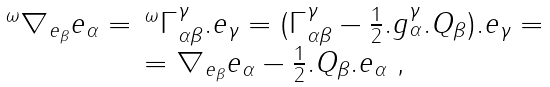<formula> <loc_0><loc_0><loc_500><loc_500>\begin{array} { c } ^ { \omega } \nabla _ { e _ { \beta } } e _ { \alpha } = \, ^ { \omega } \Gamma _ { \alpha \beta } ^ { \gamma } . e _ { \gamma } = ( \Gamma _ { \alpha \beta } ^ { \gamma } - \frac { 1 } { 2 } . g _ { \alpha } ^ { \gamma } . Q _ { \beta } ) . e _ { \gamma } = \\ = \nabla _ { e _ { \beta } } e _ { \alpha } - \frac { 1 } { 2 } . Q _ { \beta } . e _ { \alpha } \text { ,} \end{array}</formula> 